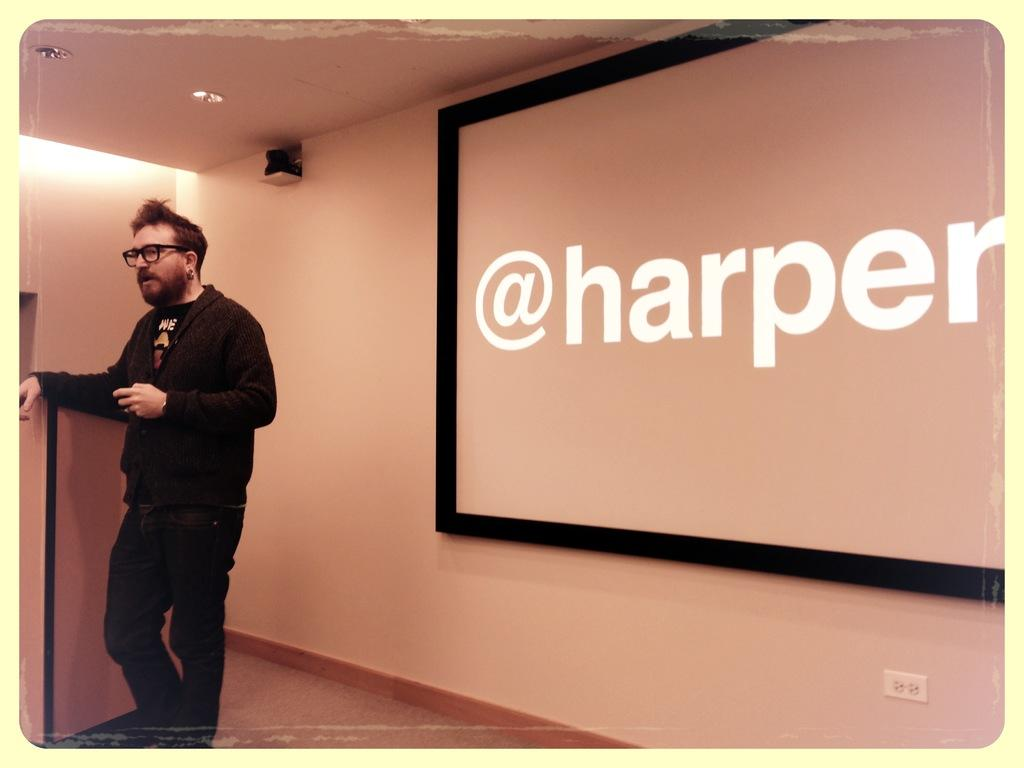What is the main subject of the image? There is a person in the image. What is the person wearing? The person is wearing a black jacket and black pants. What is the person's posture in the image? The person is standing. What can be seen in the background of the image? There is a wall, a board, and a ceiling in the background of the image. What is attached to the ceiling? There are lights attached to the ceiling. What type of crow can be seen perched on the person's shoulder in the image? There is no crow present in the image; the person is standing alone. What kind of hen is sitting on the board in the background of the image? There is no hen present in the image; the board is empty. 